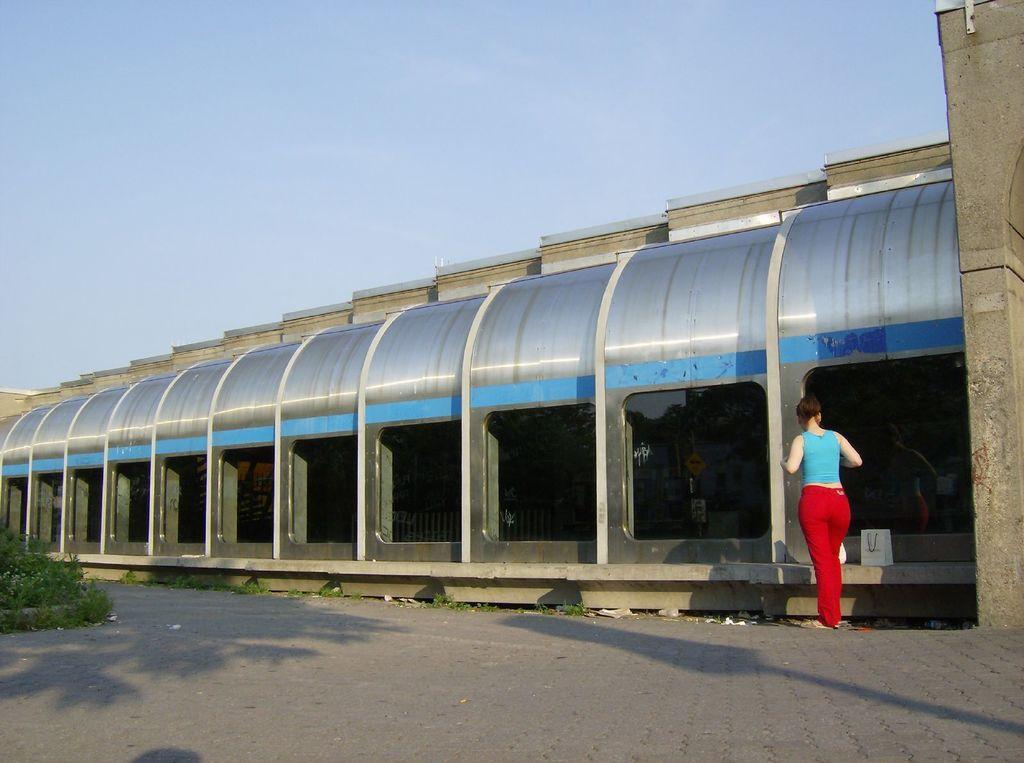Describe this image in one or two sentences. In this image I can see a shed in blue,ash and white color. One person is standing and wearing blue top and red pant. I can see few green grass and sky is in blue color. 